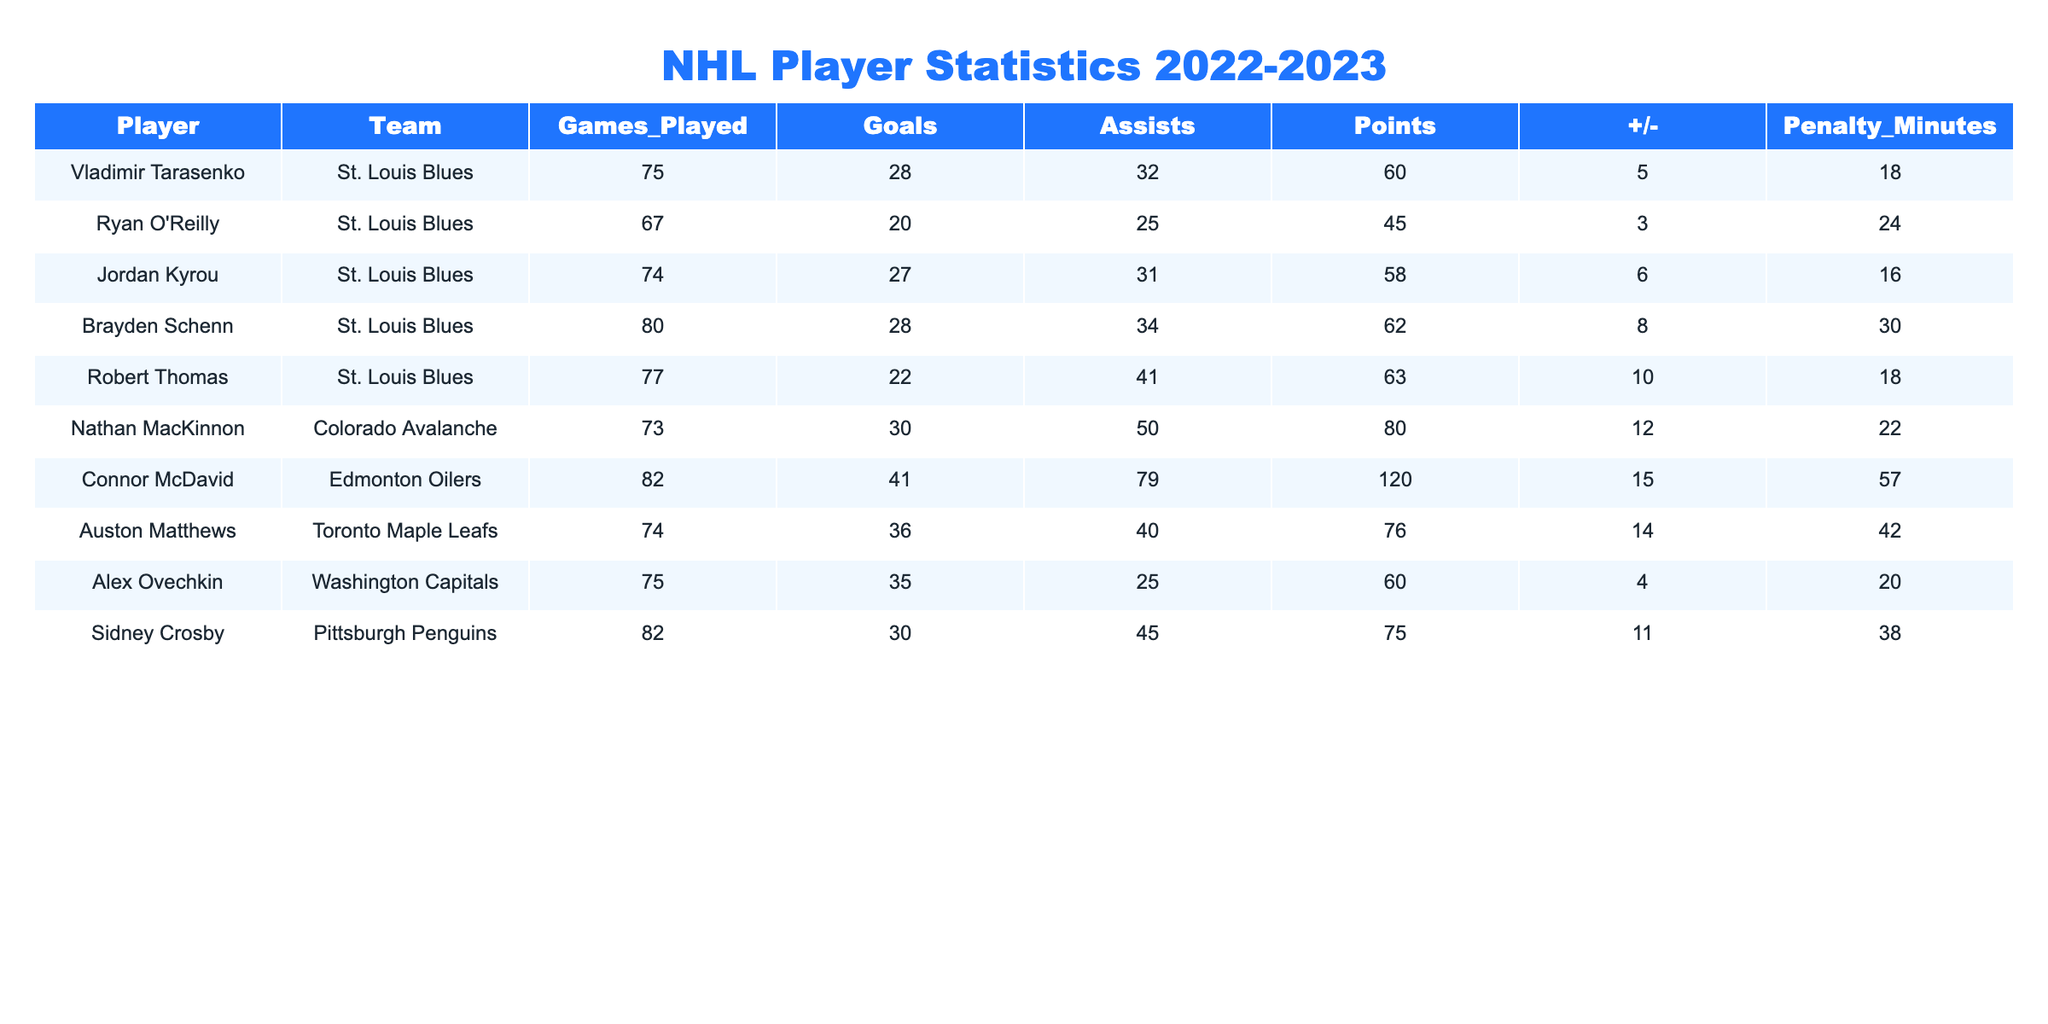What is the total number of goals scored by St. Louis Blues players in the table? The players listed from the St. Louis Blues are Vladimir Tarasenko (28 goals), Ryan O'Reilly (20 goals), Jordan Kyrou (27 goals), Brayden Schenn (28 goals), and Robert Thomas (22 goals). I sum these up: 28 + 20 + 27 + 28 + 22 = 125.
Answer: 125 Who has the highest penalty minutes among the players listed? I review the Penalty Minutes column for all players and check for the maximum value. The highest penalty minutes are 57 by Connor McDavid.
Answer: Connor McDavid What is Vladimir Tarasenko's points per game ratio? To calculate points per game, I take Vladimir Tarasenko's total points (60) and divide that by the number of games played (75). So, 60/75 = 0.8 points per game.
Answer: 0.8 Which team had more players listed: St. Louis Blues or others? There are five players from the St. Louis Blues and a total of five players from other teams (Colorado Avalanche, Edmonton Oilers, Toronto Maple Leafs, Washington Capitals, and Pittsburgh Penguins). Since both teams have the same number of players, the answer is neither.
Answer: Neither What is the average number of assists for the players in the table? To find the average, I first sum all the assists: 32 + 25 + 31 + 34 + 41 + 50 + 79 + 40 + 25 + 45 =  431 assists. Then, I divide by the total number of players (10): 431/10 = 43.1 assists per player.
Answer: 43.1 Is it true that all players listed played at least 67 games? I look at the Games Played column and identify all players. Ryan O'Reilly played 67 games, which meets the requirement, but I find that all other players also played more than this number. Thus, the statement is true.
Answer: True Who has the highest points total in the table, and what is that value? I assess the Points column, where the maximum value is for Connor McDavid with 120 points.
Answer: Connor McDavid, 120 How many more goals did Alex Ovechkin score than Brayden Schenn? I look at their goals: Alex Ovechkin scored 35 goals, while Brayden Schenn scored 28 goals. The difference is calculated as 35 - 28 = 7.
Answer: 7 What is the median number of +/− rating from all players listed? I first list the +/− values: 5, 3, 6, 8, 10, 12, 15, 4, 11. I then sort them: 3, 4, 5, 6, 8, 10, 11, 12, 15. The median is the middle value (8).
Answer: 8 